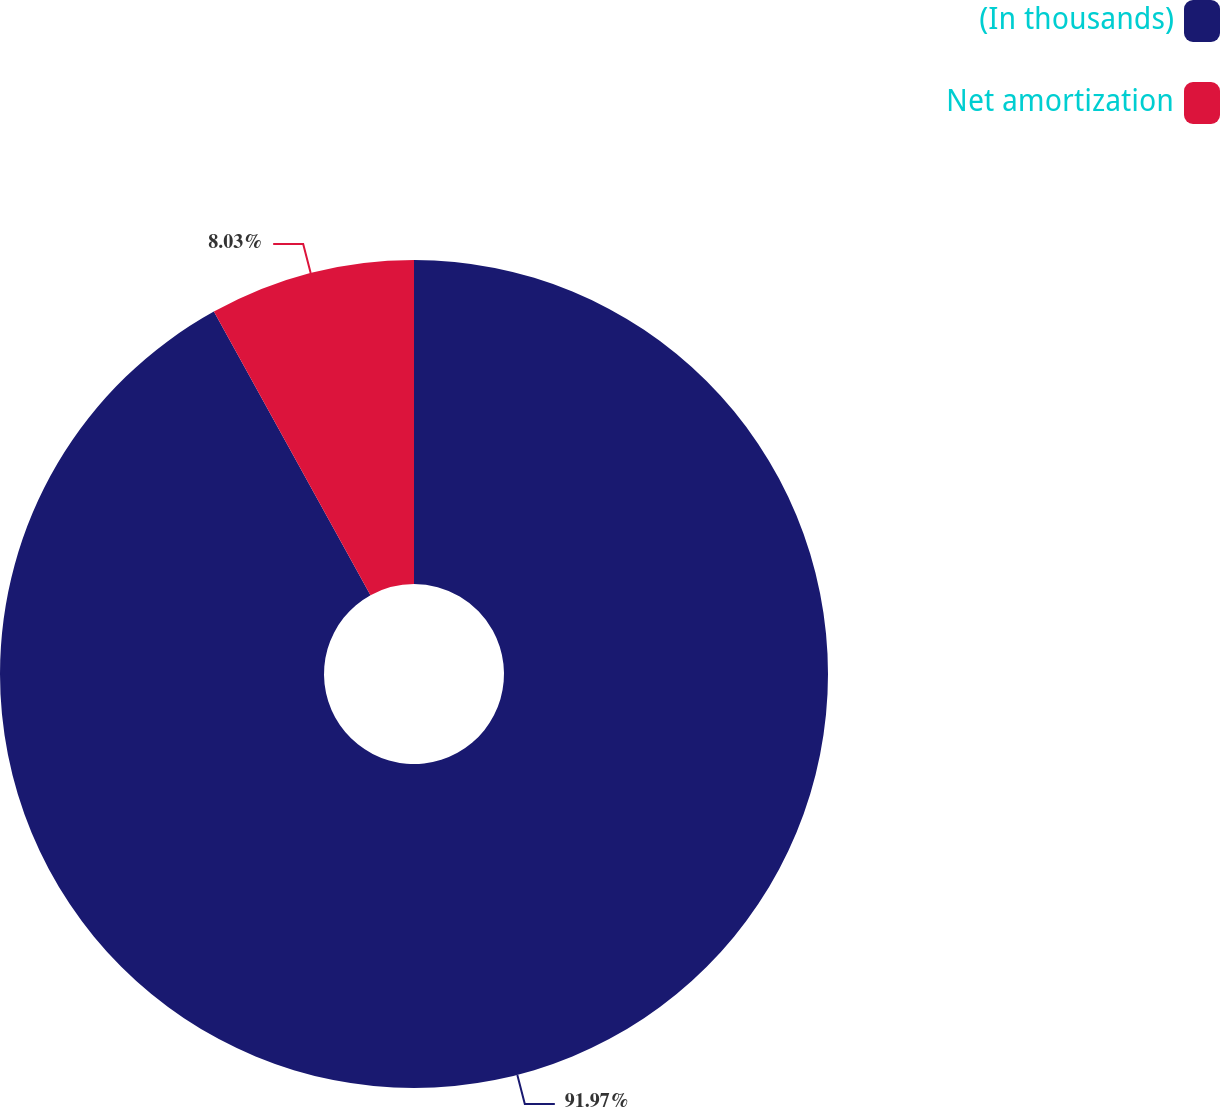Convert chart. <chart><loc_0><loc_0><loc_500><loc_500><pie_chart><fcel>(In thousands)<fcel>Net amortization<nl><fcel>91.97%<fcel>8.03%<nl></chart> 